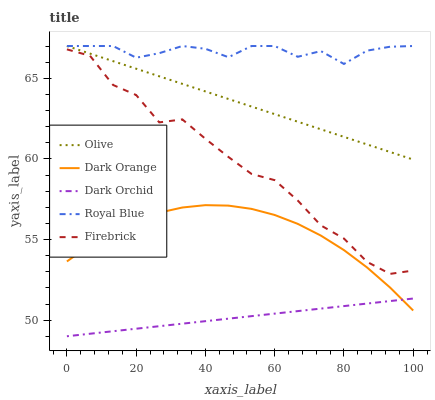Does Dark Orchid have the minimum area under the curve?
Answer yes or no. Yes. Does Royal Blue have the maximum area under the curve?
Answer yes or no. Yes. Does Dark Orange have the minimum area under the curve?
Answer yes or no. No. Does Dark Orange have the maximum area under the curve?
Answer yes or no. No. Is Olive the smoothest?
Answer yes or no. Yes. Is Firebrick the roughest?
Answer yes or no. Yes. Is Dark Orange the smoothest?
Answer yes or no. No. Is Dark Orange the roughest?
Answer yes or no. No. Does Dark Orchid have the lowest value?
Answer yes or no. Yes. Does Dark Orange have the lowest value?
Answer yes or no. No. Does Royal Blue have the highest value?
Answer yes or no. Yes. Does Dark Orange have the highest value?
Answer yes or no. No. Is Firebrick less than Olive?
Answer yes or no. Yes. Is Royal Blue greater than Firebrick?
Answer yes or no. Yes. Does Olive intersect Royal Blue?
Answer yes or no. Yes. Is Olive less than Royal Blue?
Answer yes or no. No. Is Olive greater than Royal Blue?
Answer yes or no. No. Does Firebrick intersect Olive?
Answer yes or no. No. 